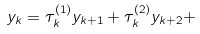<formula> <loc_0><loc_0><loc_500><loc_500>y _ { k } = \tau _ { k } ^ { ( 1 ) } y _ { k + 1 } + \tau _ { k } ^ { ( 2 ) } y _ { k + 2 } +</formula> 